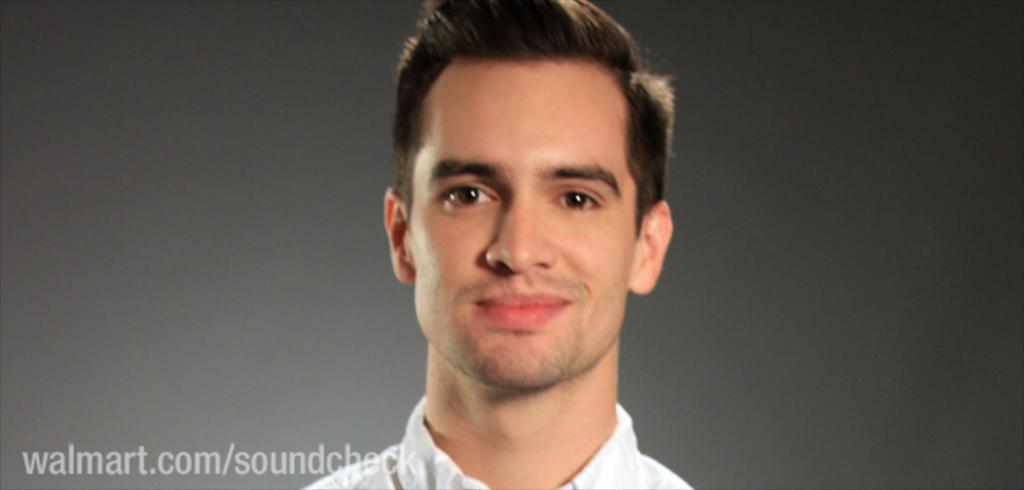What is the main subject of the image? There is a person's face in the image. What type of powder is being used by the spy in the image? There is no spy or powder present in the image; it only features a person's face. 